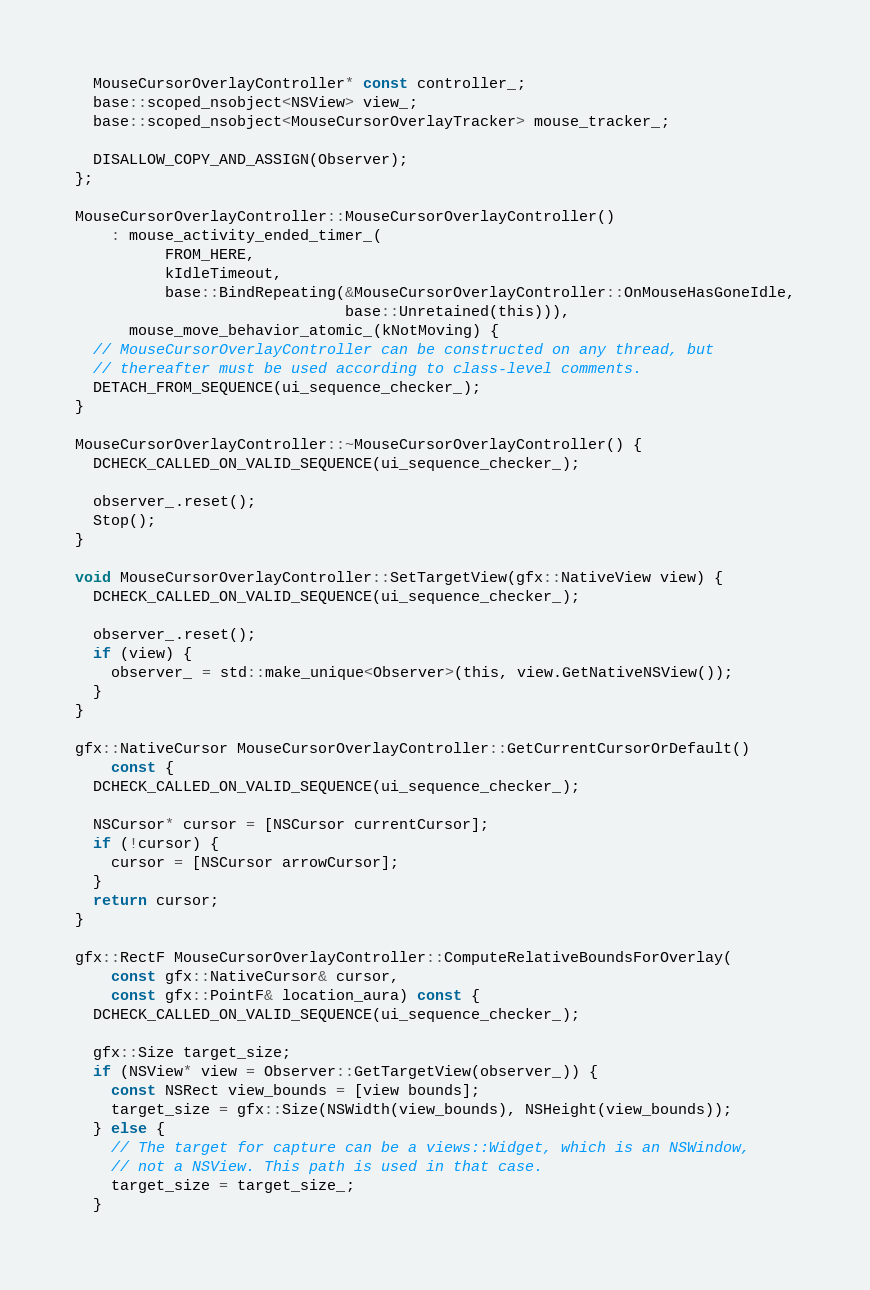Convert code to text. <code><loc_0><loc_0><loc_500><loc_500><_ObjectiveC_>  MouseCursorOverlayController* const controller_;
  base::scoped_nsobject<NSView> view_;
  base::scoped_nsobject<MouseCursorOverlayTracker> mouse_tracker_;

  DISALLOW_COPY_AND_ASSIGN(Observer);
};

MouseCursorOverlayController::MouseCursorOverlayController()
    : mouse_activity_ended_timer_(
          FROM_HERE,
          kIdleTimeout,
          base::BindRepeating(&MouseCursorOverlayController::OnMouseHasGoneIdle,
                              base::Unretained(this))),
      mouse_move_behavior_atomic_(kNotMoving) {
  // MouseCursorOverlayController can be constructed on any thread, but
  // thereafter must be used according to class-level comments.
  DETACH_FROM_SEQUENCE(ui_sequence_checker_);
}

MouseCursorOverlayController::~MouseCursorOverlayController() {
  DCHECK_CALLED_ON_VALID_SEQUENCE(ui_sequence_checker_);

  observer_.reset();
  Stop();
}

void MouseCursorOverlayController::SetTargetView(gfx::NativeView view) {
  DCHECK_CALLED_ON_VALID_SEQUENCE(ui_sequence_checker_);

  observer_.reset();
  if (view) {
    observer_ = std::make_unique<Observer>(this, view.GetNativeNSView());
  }
}

gfx::NativeCursor MouseCursorOverlayController::GetCurrentCursorOrDefault()
    const {
  DCHECK_CALLED_ON_VALID_SEQUENCE(ui_sequence_checker_);

  NSCursor* cursor = [NSCursor currentCursor];
  if (!cursor) {
    cursor = [NSCursor arrowCursor];
  }
  return cursor;
}

gfx::RectF MouseCursorOverlayController::ComputeRelativeBoundsForOverlay(
    const gfx::NativeCursor& cursor,
    const gfx::PointF& location_aura) const {
  DCHECK_CALLED_ON_VALID_SEQUENCE(ui_sequence_checker_);

  gfx::Size target_size;
  if (NSView* view = Observer::GetTargetView(observer_)) {
    const NSRect view_bounds = [view bounds];
    target_size = gfx::Size(NSWidth(view_bounds), NSHeight(view_bounds));
  } else {
    // The target for capture can be a views::Widget, which is an NSWindow,
    // not a NSView. This path is used in that case.
    target_size = target_size_;
  }
</code> 